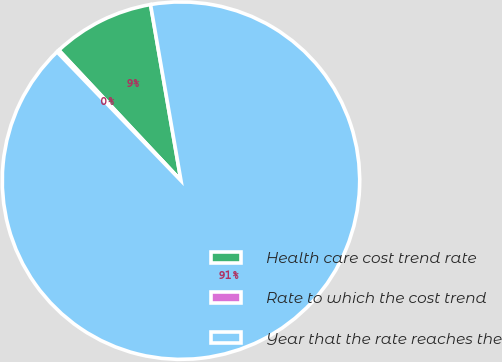Convert chart. <chart><loc_0><loc_0><loc_500><loc_500><pie_chart><fcel>Health care cost trend rate<fcel>Rate to which the cost trend<fcel>Year that the rate reaches the<nl><fcel>9.25%<fcel>0.22%<fcel>90.52%<nl></chart> 